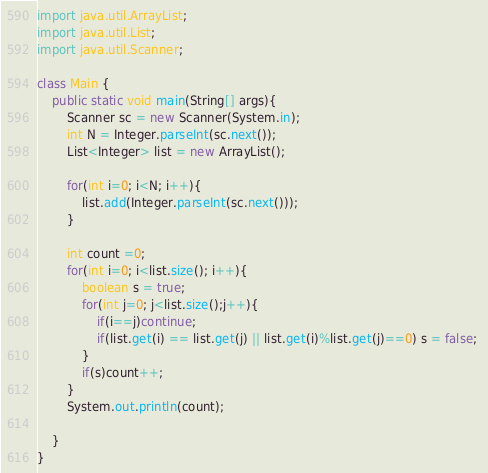<code> <loc_0><loc_0><loc_500><loc_500><_Java_>import java.util.ArrayList;
import java.util.List;
import java.util.Scanner;

class Main {
	public static void main(String[] args){
		Scanner sc = new Scanner(System.in);
		int N = Integer.parseInt(sc.next());
		List<Integer> list = new ArrayList();
		
		for(int i=0; i<N; i++){
			list.add(Integer.parseInt(sc.next()));
		}
		
		int count =0;
		for(int i=0; i<list.size(); i++){
			boolean s = true;
			for(int j=0; j<list.size();j++){
				if(i==j)continue;
				if(list.get(i) == list.get(j) || list.get(i)%list.get(j)==0) s = false; 
			}
			if(s)count++;
		}
		System.out.println(count);
		
	}
}
</code> 